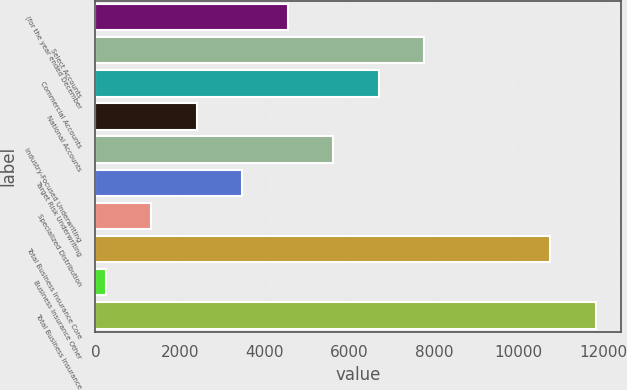Convert chart. <chart><loc_0><loc_0><loc_500><loc_500><bar_chart><fcel>(for the year ended December<fcel>Select Accounts<fcel>Commercial Accounts<fcel>National Accounts<fcel>Industry-Focused Underwriting<fcel>Target Risk Underwriting<fcel>Specialized Distribution<fcel>Total Business Insurance Core<fcel>Business Insurance Other<fcel>Total Business Insurance<nl><fcel>4547.8<fcel>7773.4<fcel>6698.2<fcel>2397.4<fcel>5623<fcel>3472.6<fcel>1322.2<fcel>10752<fcel>247<fcel>11827.2<nl></chart> 